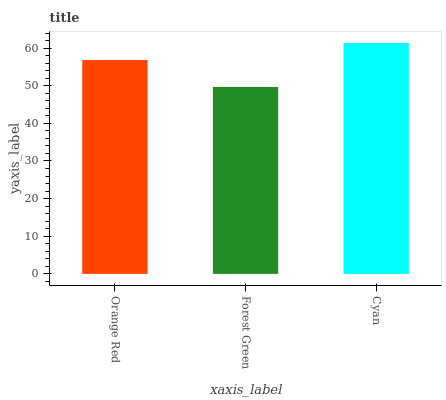Is Forest Green the minimum?
Answer yes or no. Yes. Is Cyan the maximum?
Answer yes or no. Yes. Is Cyan the minimum?
Answer yes or no. No. Is Forest Green the maximum?
Answer yes or no. No. Is Cyan greater than Forest Green?
Answer yes or no. Yes. Is Forest Green less than Cyan?
Answer yes or no. Yes. Is Forest Green greater than Cyan?
Answer yes or no. No. Is Cyan less than Forest Green?
Answer yes or no. No. Is Orange Red the high median?
Answer yes or no. Yes. Is Orange Red the low median?
Answer yes or no. Yes. Is Forest Green the high median?
Answer yes or no. No. Is Forest Green the low median?
Answer yes or no. No. 